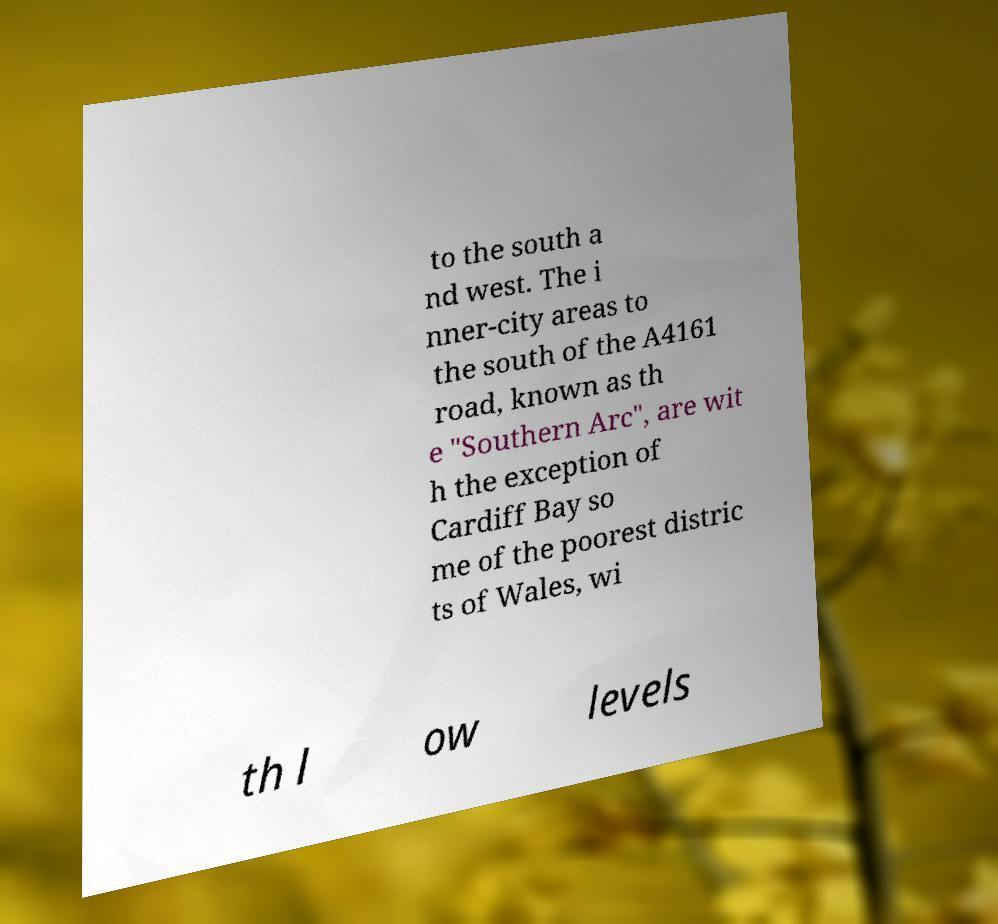Can you read and provide the text displayed in the image?This photo seems to have some interesting text. Can you extract and type it out for me? to the south a nd west. The i nner-city areas to the south of the A4161 road, known as th e "Southern Arc", are wit h the exception of Cardiff Bay so me of the poorest distric ts of Wales, wi th l ow levels 